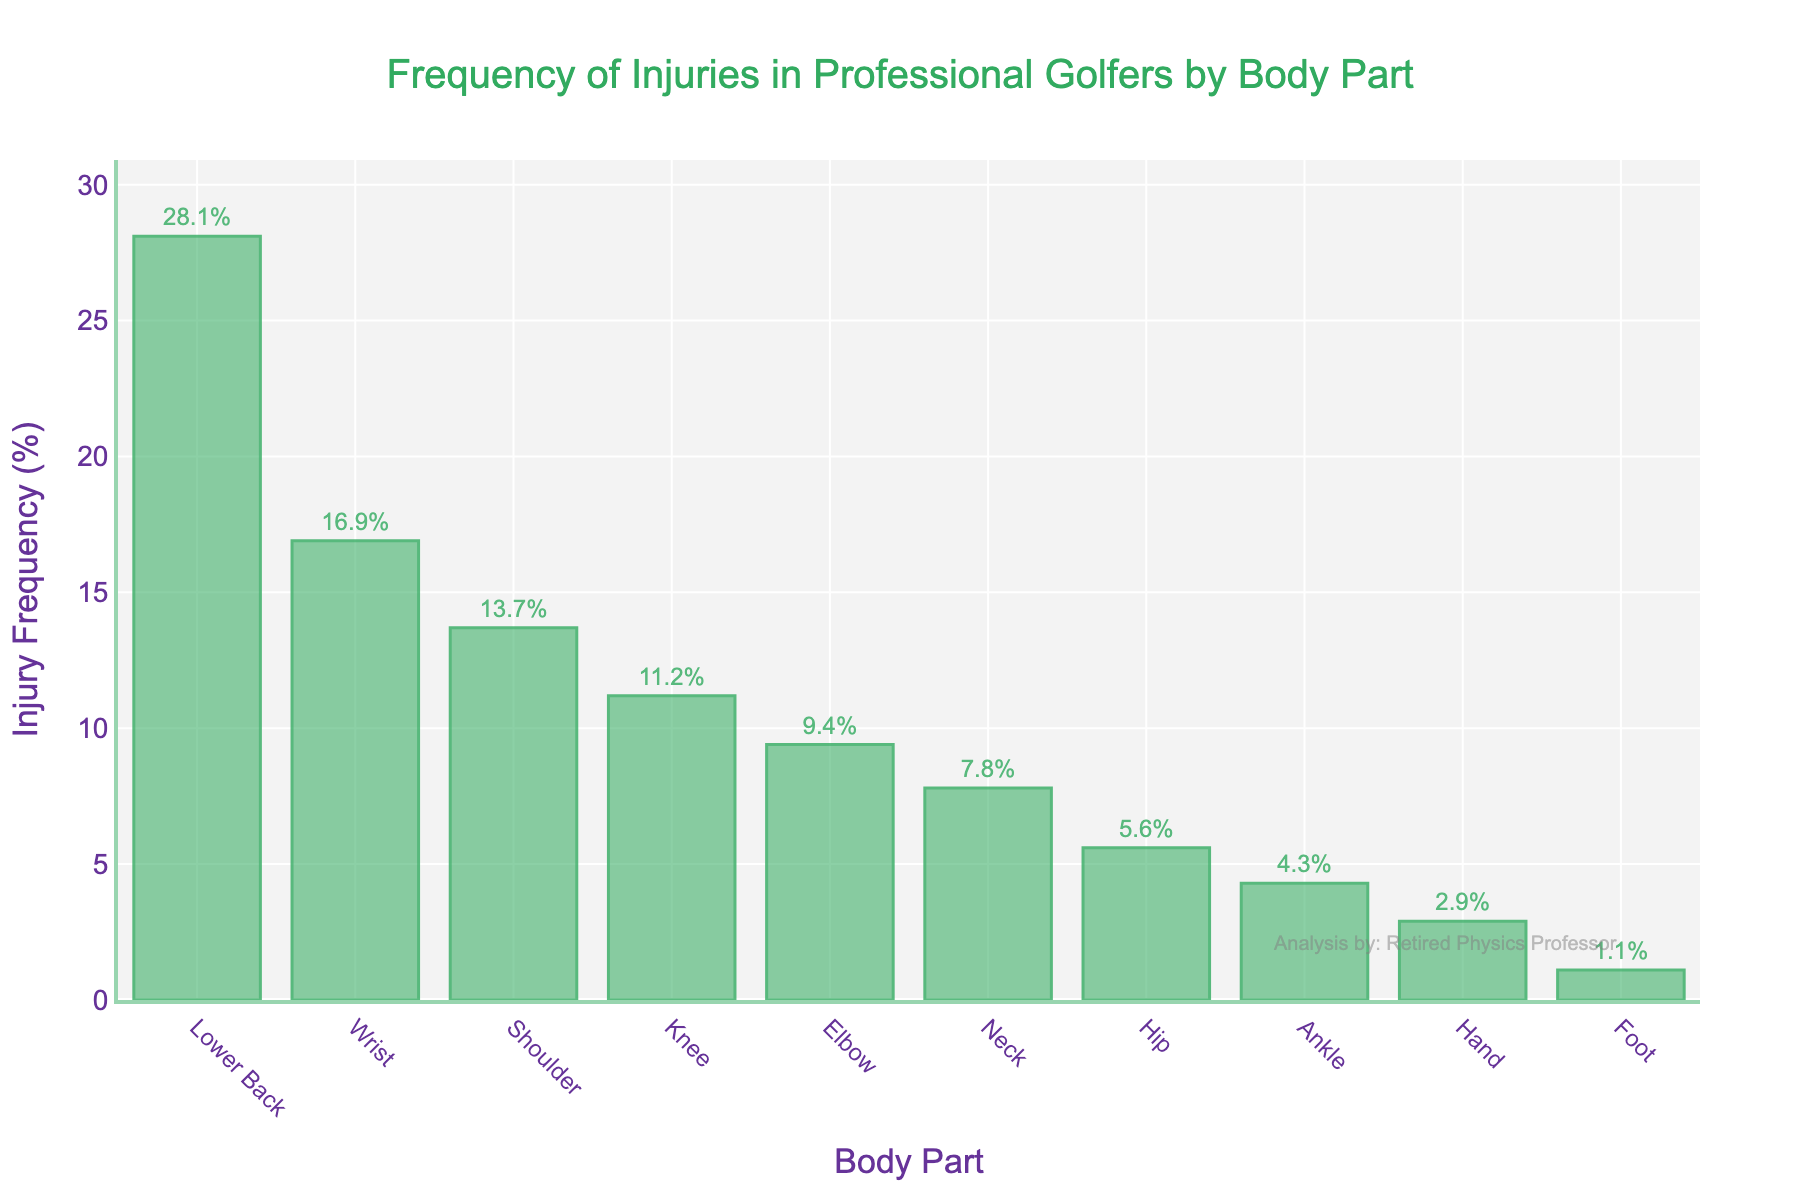What is the most common injury among professional golfers? The highest bar in the chart represents the most common injury. Here, the Lower Back shows the highest bar with an injury frequency of 28.1%.
Answer: Lower Back Which part of the body has the least frequency of injuries? The lowest bar in the chart corresponds to the body part with the least frequency of injuries. Here, the Foot shows the lowest bar with an injury frequency of 1.1%.
Answer: Foot How much higher is the frequency of Lower Back injuries compared to Knee injuries? The bar for Lower Back shows an injury frequency of 28.1%, while the bar for Knee shows an injury frequency of 11.2%. Subtracting 11.2% from 28.1% gives 16.9%.
Answer: 16.9% What is the combined frequency of injuries for the Shoulder and Elbow? The frequency of Shoulder injuries is 13.7%, and the frequency for Elbow injuries is 9.4%. Adding these together gives 23.1%.
Answer: 23.1% Which body part has a higher injury frequency: Hip or Neck? By comparing the heights of the bars for Hip (5.6%) and Neck (7.8%), the Neck has a higher injury frequency.
Answer: Neck How many body parts have an injury frequency above 10%? The bars for Lower Back (28.1%), Wrist (16.9%), Shoulder (13.7%), and Knee (11.2%) are above 10%. Counting these gives 4 body parts.
Answer: 4 How does the frequency of Wrist injuries compare to the combined frequency of Ankle and Hand injuries? The frequency of Wrist injuries is 16.9%. The combined frequency of Ankle (4.3%) and Hand (2.9%) is 7.2%. Comparing 16.9% and 7.2%, the Wrist injury frequency is higher.
Answer: Wrist injuries are higher What is the average frequency of injuries among all the body parts? Summing up all injury frequencies: 28.1% + 16.9% + 13.7% + 11.2% + 9.4% + 7.8% + 5.6% + 4.3% + 2.9% + 1.1% = 101%. Dividing 101% by 10 body parts gives an average of 10.1%.
Answer: 10.1% Which has the higher frequency of injuries: Elbow or Knee? Comparing the heights of the bars for Elbow (9.4%) and Knee (11.2%), the Knee has a higher injury frequency.
Answer: Knee What is the frequency range of injuries seen in the chart? The highest injury frequency is for the Lower Back (28.1%), and the lowest is for the Foot (1.1%). Subtracting the lowest from the highest gives the range: 28.1% - 1.1% = 27%.
Answer: 27% 